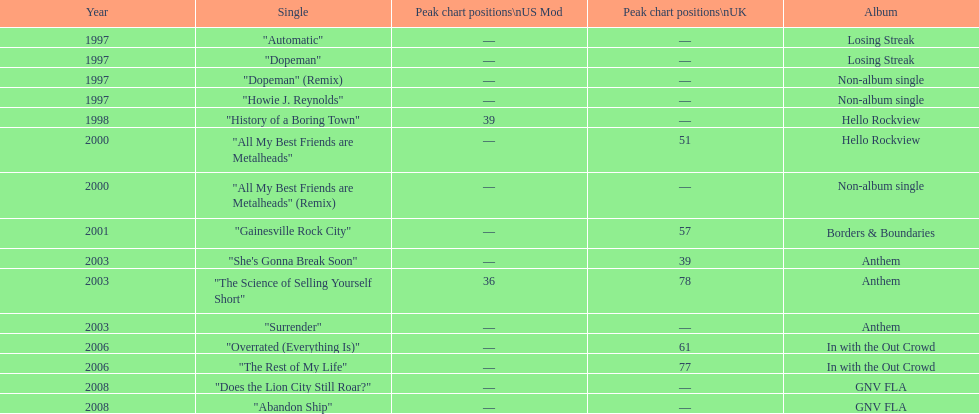What was the first single to earn a chart position? "History of a Boring Town". Parse the full table. {'header': ['Year', 'Single', 'Peak chart positions\\nUS Mod', 'Peak chart positions\\nUK', 'Album'], 'rows': [['1997', '"Automatic"', '—', '—', 'Losing Streak'], ['1997', '"Dopeman"', '—', '—', 'Losing Streak'], ['1997', '"Dopeman" (Remix)', '—', '—', 'Non-album single'], ['1997', '"Howie J. Reynolds"', '—', '—', 'Non-album single'], ['1998', '"History of a Boring Town"', '39', '—', 'Hello Rockview'], ['2000', '"All My Best Friends are Metalheads"', '—', '51', 'Hello Rockview'], ['2000', '"All My Best Friends are Metalheads" (Remix)', '—', '—', 'Non-album single'], ['2001', '"Gainesville Rock City"', '—', '57', 'Borders & Boundaries'], ['2003', '"She\'s Gonna Break Soon"', '—', '39', 'Anthem'], ['2003', '"The Science of Selling Yourself Short"', '36', '78', 'Anthem'], ['2003', '"Surrender"', '—', '—', 'Anthem'], ['2006', '"Overrated (Everything Is)"', '—', '61', 'In with the Out Crowd'], ['2006', '"The Rest of My Life"', '—', '77', 'In with the Out Crowd'], ['2008', '"Does the Lion City Still Roar?"', '—', '—', 'GNV FLA'], ['2008', '"Abandon Ship"', '—', '—', 'GNV FLA']]} 